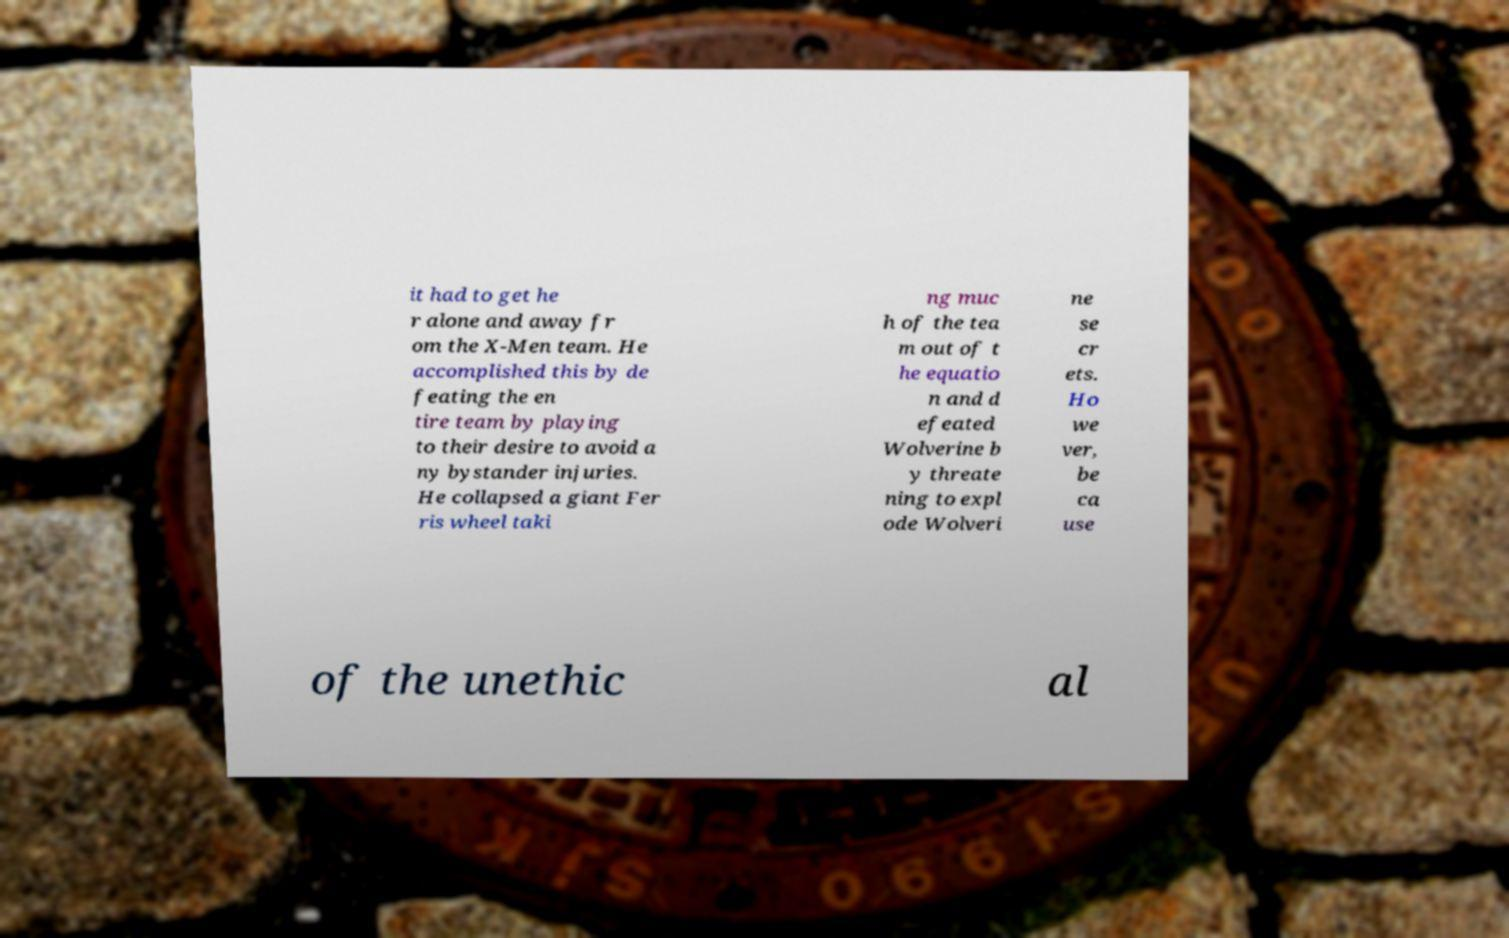Please identify and transcribe the text found in this image. it had to get he r alone and away fr om the X-Men team. He accomplished this by de feating the en tire team by playing to their desire to avoid a ny bystander injuries. He collapsed a giant Fer ris wheel taki ng muc h of the tea m out of t he equatio n and d efeated Wolverine b y threate ning to expl ode Wolveri ne se cr ets. Ho we ver, be ca use of the unethic al 